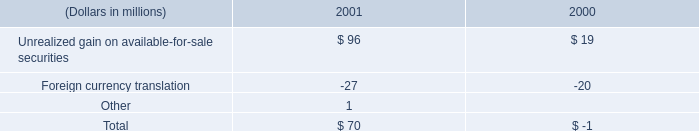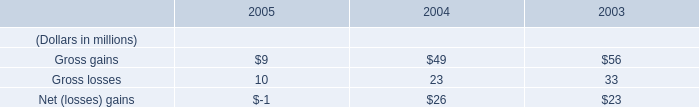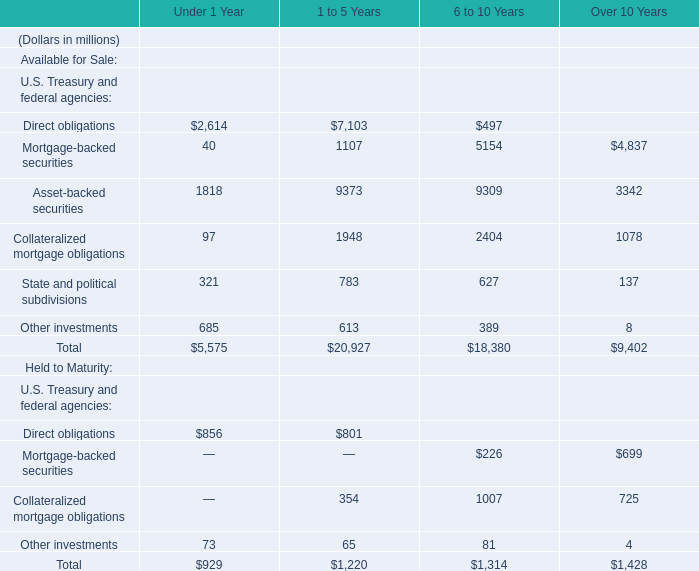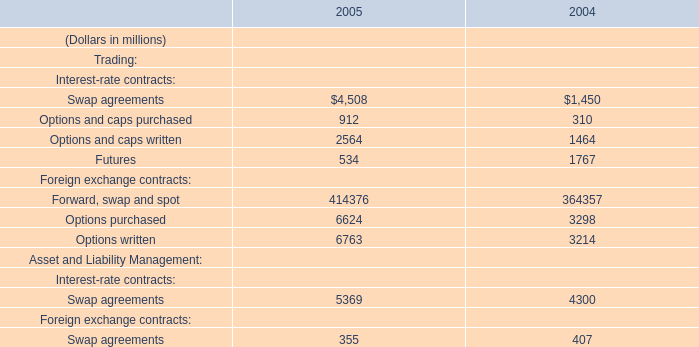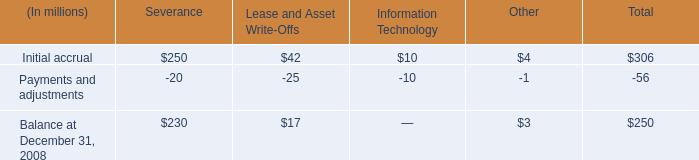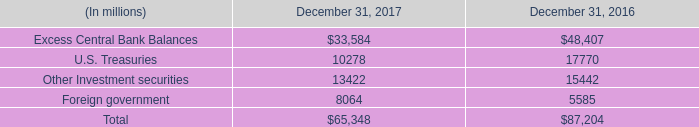assuming that the outstanding number of shares is 100 million before the 2001 stock split , how many shares will be outstanding after the split , in millions? 
Computations: (100 * 2)
Answer: 200.0. 